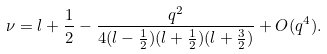Convert formula to latex. <formula><loc_0><loc_0><loc_500><loc_500>\nu = l + \frac { 1 } { 2 } - \frac { q ^ { 2 } } { 4 ( l - \frac { 1 } { 2 } ) ( l + \frac { 1 } { 2 } ) ( l + \frac { 3 } { 2 } ) } + O ( q ^ { 4 } ) .</formula> 